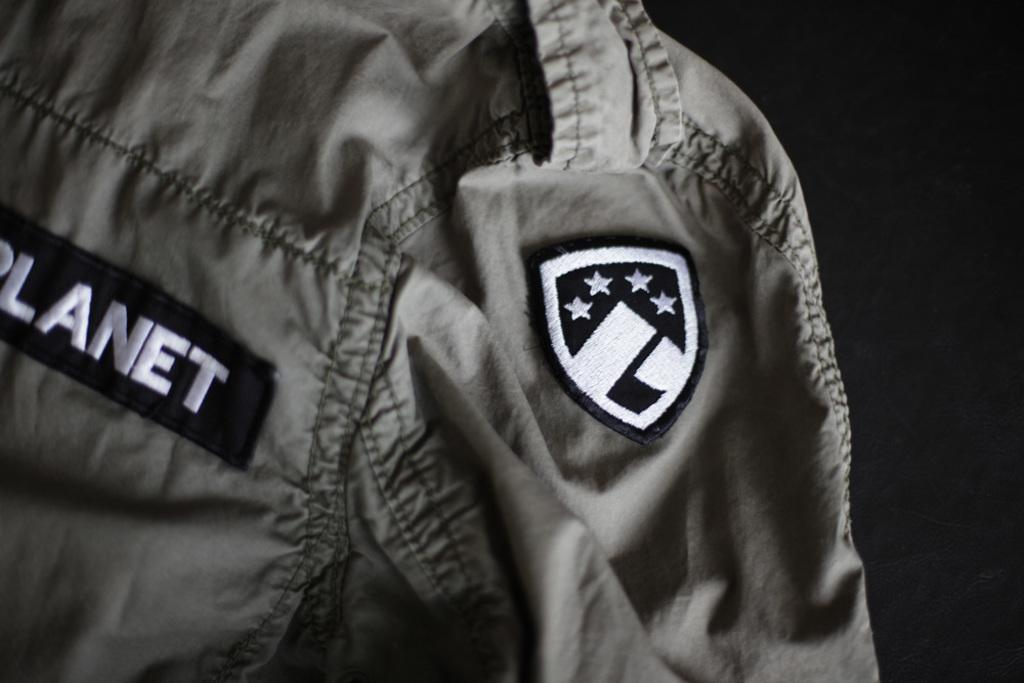<image>
Describe the image concisely. The word planet can be seen on a jacket with a patch on it. 